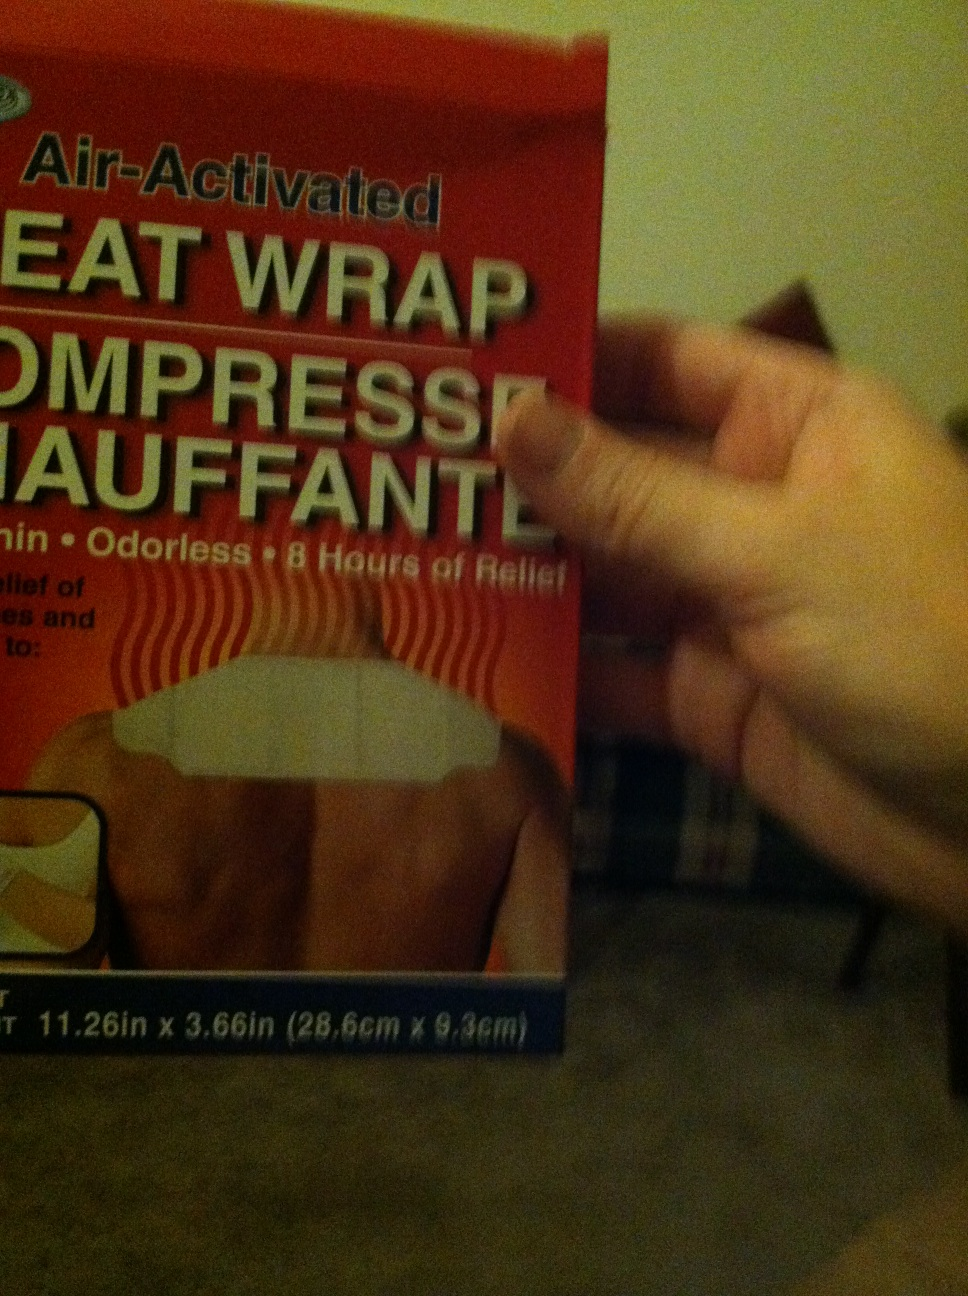What are the uses of this item? Heat wraps like the one shown are commonly used to relieve muscle aches, joint stiffness, and minor pain. They can be particularly helpful for conditions such as arthritis, back pain, or menstrual cramps. 